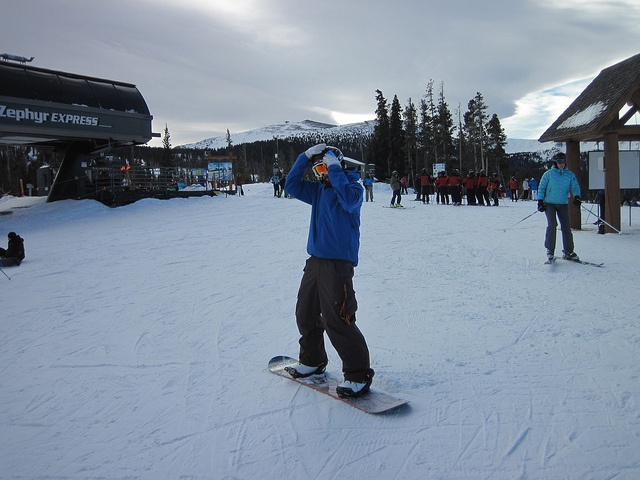Describe the objects in this image and their specific colors. I can see people in gray, black, navy, and blue tones, people in gray, black, teal, navy, and blue tones, people in gray, black, and darkgray tones, snowboard in gray and darkgray tones, and people in gray, black, maroon, and navy tones in this image. 